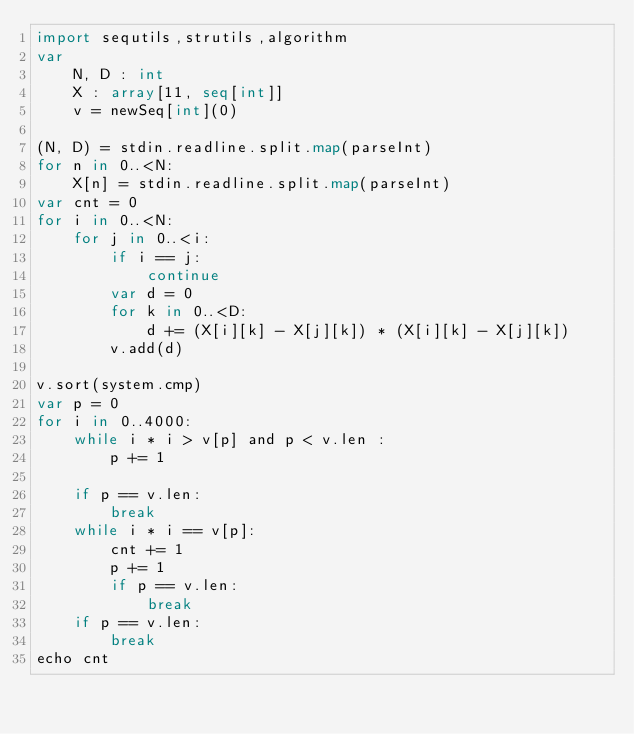<code> <loc_0><loc_0><loc_500><loc_500><_Nim_>import sequtils,strutils,algorithm
var
    N, D : int
    X : array[11, seq[int]]
    v = newSeq[int](0)
    
(N, D) = stdin.readline.split.map(parseInt)
for n in 0..<N:
    X[n] = stdin.readline.split.map(parseInt)
var cnt = 0
for i in 0..<N:
    for j in 0..<i:
        if i == j:
            continue
        var d = 0
        for k in 0..<D:
            d += (X[i][k] - X[j][k]) * (X[i][k] - X[j][k])
        v.add(d)

v.sort(system.cmp)
var p = 0
for i in 0..4000:
    while i * i > v[p] and p < v.len :
        p += 1
        
    if p == v.len:
        break
    while i * i == v[p]:
        cnt += 1
        p += 1
        if p == v.len:
            break
    if p == v.len:
        break
echo cnt
        
    </code> 